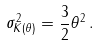<formula> <loc_0><loc_0><loc_500><loc_500>\sigma ^ { 2 } _ { K ( \theta ) } = \frac { 3 } { 2 } \theta ^ { 2 } \, .</formula> 